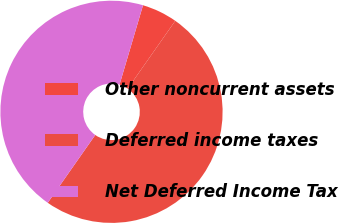<chart> <loc_0><loc_0><loc_500><loc_500><pie_chart><fcel>Other noncurrent assets<fcel>Deferred income taxes<fcel>Net Deferred Income Tax<nl><fcel>5.15%<fcel>50.0%<fcel>44.85%<nl></chart> 